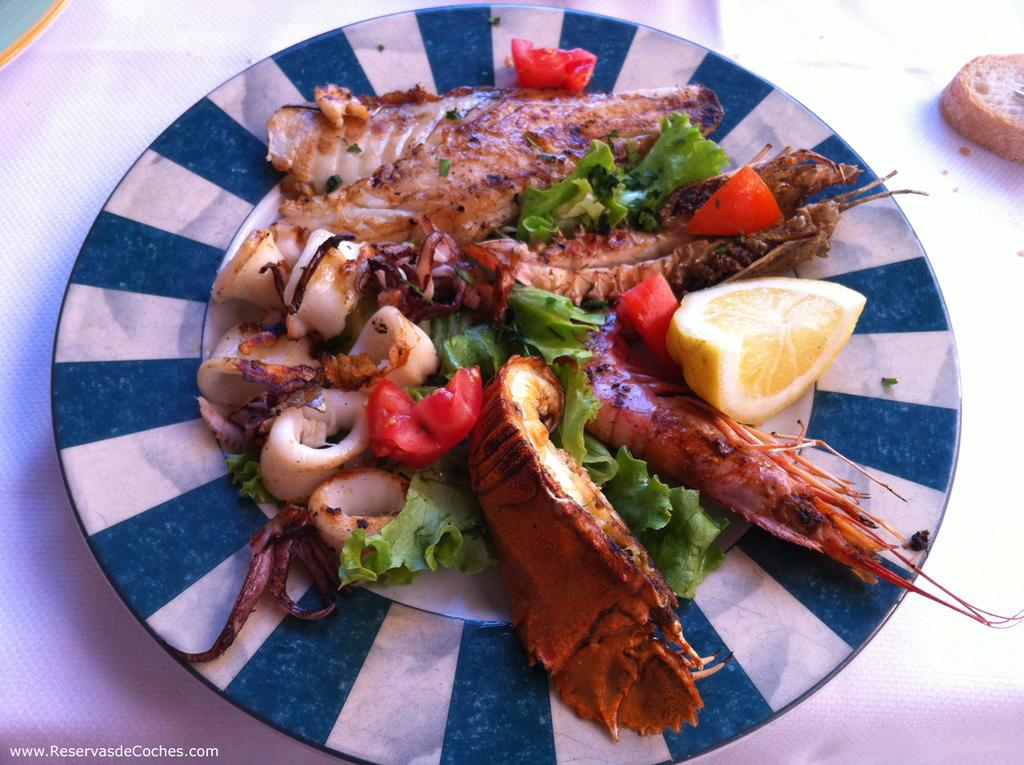What type of dish is featured in the image? There is a salad with fried prawns in the image. What is placed on the plate with the salad? There is a lemon slice on the plate in the image. Where is the bread located in the image? There is a bread slice on the right side corner of the table in the image. How are the salad, lemon slice, and bread arranged in the image? The salad and bread are on a plate, and the plate is on a table. Can you see a carriage in the image? No, there is no carriage present in the image. Is there a toothbrush on the table in the image? No, there is no toothbrush present in the image. 